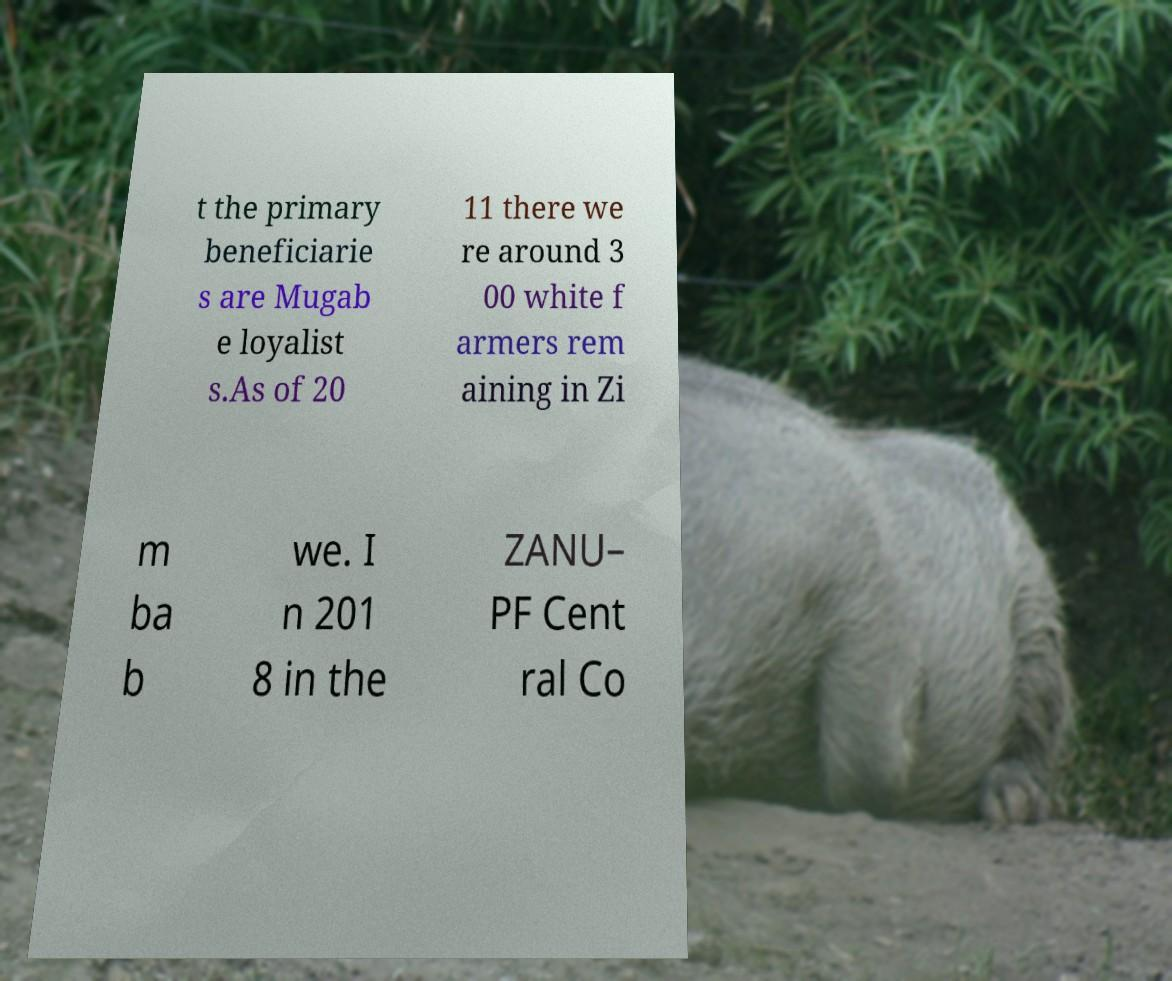Could you assist in decoding the text presented in this image and type it out clearly? t the primary beneficiarie s are Mugab e loyalist s.As of 20 11 there we re around 3 00 white f armers rem aining in Zi m ba b we. I n 201 8 in the ZANU– PF Cent ral Co 